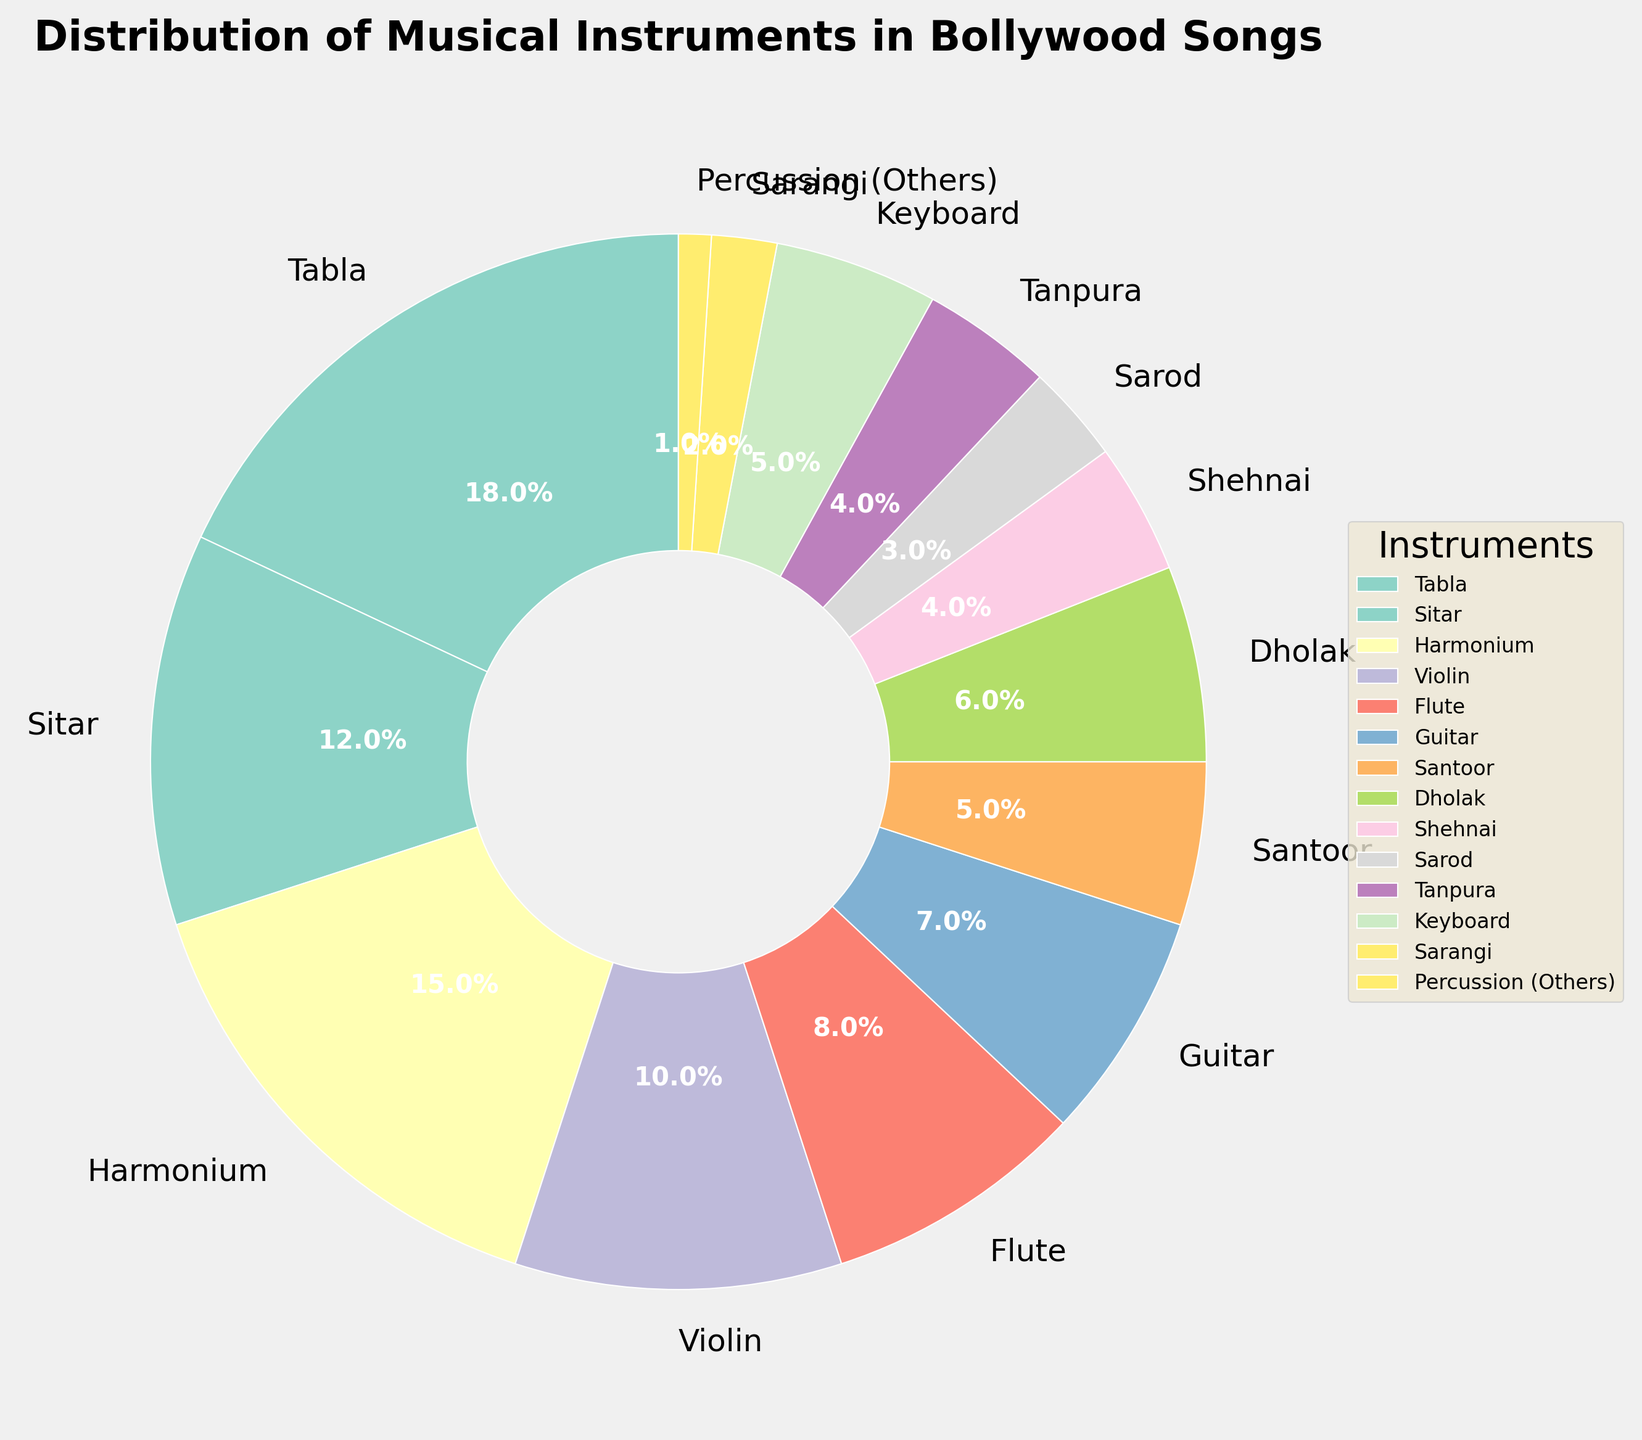What percentage of the instruments used together (Percussion (Others), Santoor, Dholak)? To find the combined percentage, sum the individual percentages: Percussion (Others) = 1%, Santoor = 5%, and Dholak = 6%. Therefore, 1% + 5% + 6% = 12%.
Answer: 12% Which instrument is the most frequently used in Bollywood songs? The analysis can be derived from the wedge size and the provided labels. The Tabla occupies the largest part of the pie, with a percentage of 18%.
Answer: Tabla How many instruments have a percentage greater than 10%? There are 4 instruments above 10%: Tabla (18%), Sitar (12%), Harmonium (15%), and Violin (10%).
Answer: 4 Which instrument group has a higher percentage: String instruments (Sitar, Violin, Sarod, Tanpura) or Wind instruments (Flute, Shehnai)? Calculate the sums of each group. String instruments: Sitar (12%) + Violin (10%) + Sarod (3%) + Tanpura (4%) = 29%. Wind instruments: Flute (8%) + Shehnai (4%) = 12%. Thus, String instruments have a higher percentage.
Answer: String instruments What is the sum of the percentages for Harmonium, Keyboard, and Sarangi? Sum the given percentages: Harmonium = 15%, Keyboard = 5%, and Sarangi = 2%. Thus, 15% + 5% + 2% = 22%.
Answer: 22% Which two instruments have an equal percentage usage in Bollywood songs? By inspecting the pie chart, both Shehnai and Tanpura have an equal percentage of 4%.
Answer: Shehnai and Tanpura Which type of instrument usage contributes more than double the percentage of Sarangi? To determine this, check for instruments with more than twice 2% (Sarangi's percentage). Instruments meeting this criterion are Tabla (18%), Sitar (12%), Harmonium (15%), Violin (10%), Flute (8%), and Guitar (7%).
Answer: Tabla, Sitar, Harmonium, Violin, Flute, Guitar Is the percentage of Flute usage greater than the combined usage of Keyboard and Percussion (Others)? Calculate the combined percentage of Keyboard and Percussion: 5% (Keyboard) + 1% (Percussion (Others)) = 6%. Compare this to Flute's percentage: 8% > 6%.
Answer: Yes What is the percentage difference between the most and least commonly used instruments? The most commonly used instrument is Tabla (18%), and the least used is Percussion (Others) (1%). Therefore, 18% - 1% = 17%.
Answer: 17% Which instrument types are used in exactly 5% of Bollywood songs? Examining the chart, the two instruments with exactly 5% are Santoor and Keyboard.
Answer: Santoor and Keyboard 